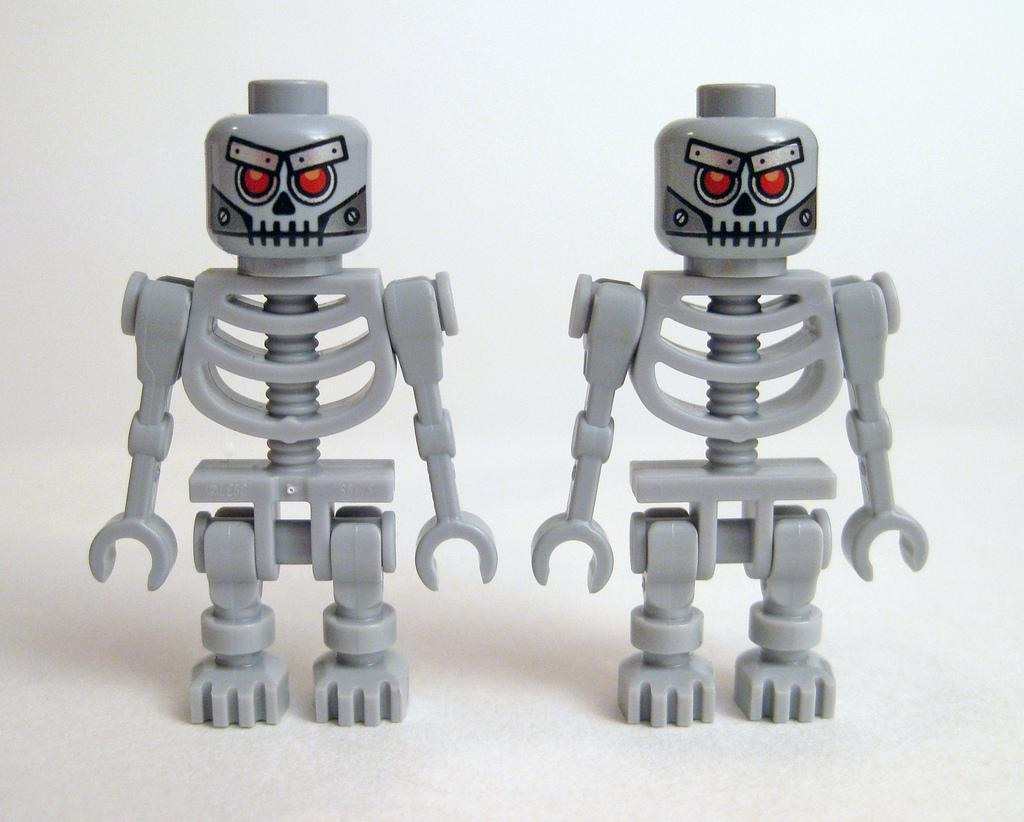How many toys are visible in the image? There are two toys in the image. What type of impulse can be seen affecting the toys in the image? There is no impulse affecting the toys in the image; they are stationary. Can you describe the playground where the toys are located in the image? There is no playground present in the image; it only features two toys. 